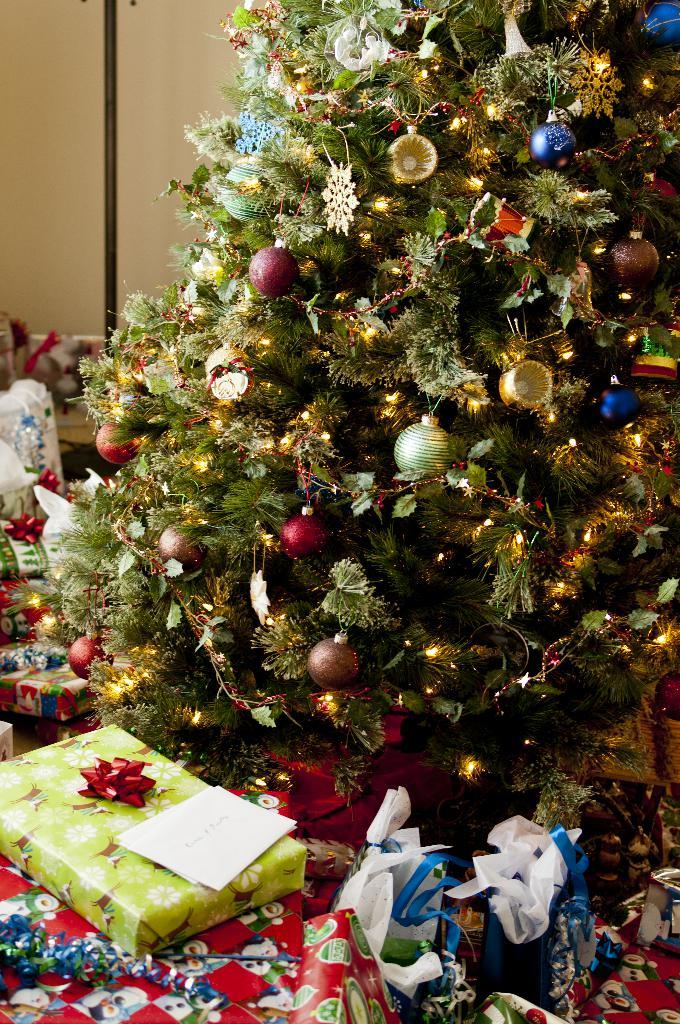What is the main subject in the image? There is a plant in the image. What makes the plant stand out or appear decorative? The plant has decorative items and lights. What is placed in front of the plant? There are gift boxes and other things in front of the plant. What can be seen behind the plant? There is a wall behind the plant. What type of card is being used to water the plant in the image? There is no card present in the image, and the plant is not being watered. 